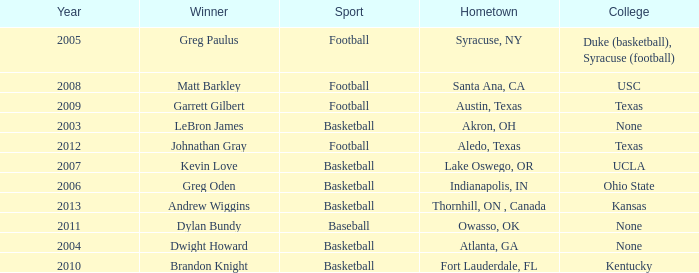I'm looking to parse the entire table for insights. Could you assist me with that? {'header': ['Year', 'Winner', 'Sport', 'Hometown', 'College'], 'rows': [['2005', 'Greg Paulus', 'Football', 'Syracuse, NY', 'Duke (basketball), Syracuse (football)'], ['2008', 'Matt Barkley', 'Football', 'Santa Ana, CA', 'USC'], ['2009', 'Garrett Gilbert', 'Football', 'Austin, Texas', 'Texas'], ['2003', 'LeBron James', 'Basketball', 'Akron, OH', 'None'], ['2012', 'Johnathan Gray', 'Football', 'Aledo, Texas', 'Texas'], ['2007', 'Kevin Love', 'Basketball', 'Lake Oswego, OR', 'UCLA'], ['2006', 'Greg Oden', 'Basketball', 'Indianapolis, IN', 'Ohio State'], ['2013', 'Andrew Wiggins', 'Basketball', 'Thornhill, ON , Canada', 'Kansas'], ['2011', 'Dylan Bundy', 'Baseball', 'Owasso, OK', 'None'], ['2004', 'Dwight Howard', 'Basketball', 'Atlanta, GA', 'None'], ['2010', 'Brandon Knight', 'Basketball', 'Fort Lauderdale, FL', 'Kentucky']]} What is Hometown, when Sport is "Basketball", and when Winner is "Dwight Howard"? Atlanta, GA. 